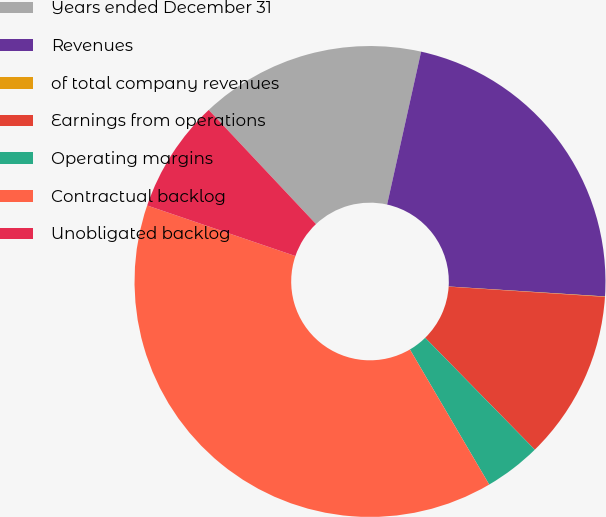Convert chart to OTSL. <chart><loc_0><loc_0><loc_500><loc_500><pie_chart><fcel>Years ended December 31<fcel>Revenues<fcel>of total company revenues<fcel>Earnings from operations<fcel>Operating margins<fcel>Contractual backlog<fcel>Unobligated backlog<nl><fcel>15.49%<fcel>22.53%<fcel>0.03%<fcel>11.62%<fcel>3.89%<fcel>38.68%<fcel>7.76%<nl></chart> 